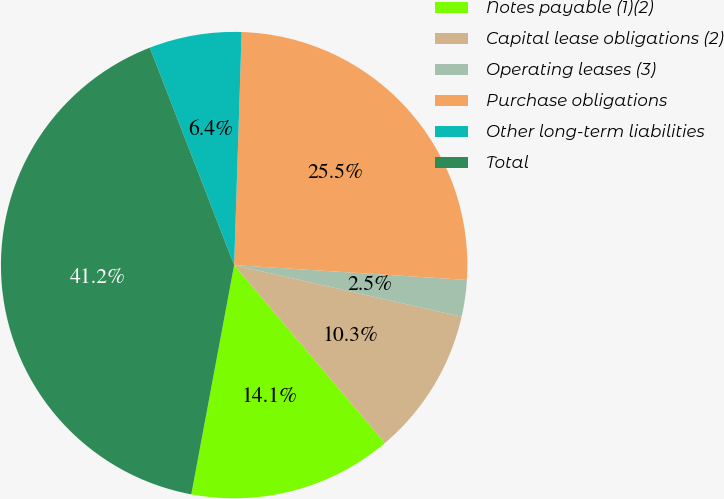Convert chart to OTSL. <chart><loc_0><loc_0><loc_500><loc_500><pie_chart><fcel>Notes payable (1)(2)<fcel>Capital lease obligations (2)<fcel>Operating leases (3)<fcel>Purchase obligations<fcel>Other long-term liabilities<fcel>Total<nl><fcel>14.13%<fcel>10.26%<fcel>2.54%<fcel>25.5%<fcel>6.4%<fcel>41.17%<nl></chart> 